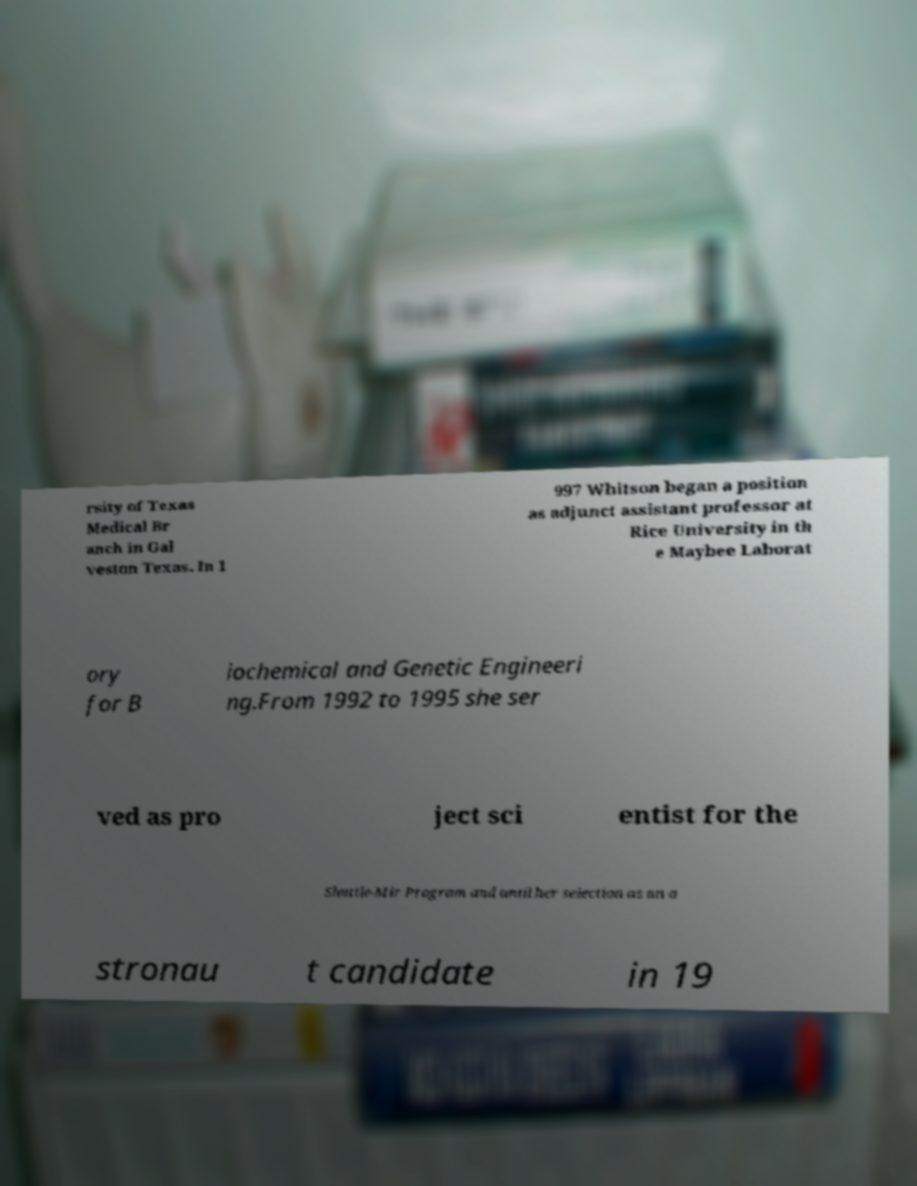Can you accurately transcribe the text from the provided image for me? rsity of Texas Medical Br anch in Gal veston Texas. In 1 997 Whitson began a position as adjunct assistant professor at Rice University in th e Maybee Laborat ory for B iochemical and Genetic Engineeri ng.From 1992 to 1995 she ser ved as pro ject sci entist for the Shuttle-Mir Program and until her selection as an a stronau t candidate in 19 